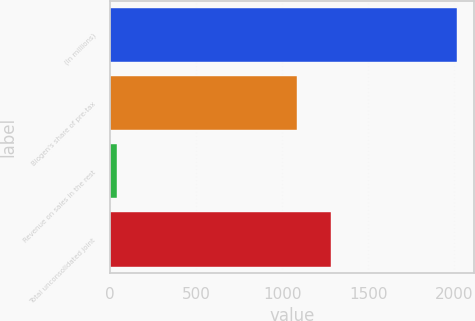Convert chart to OTSL. <chart><loc_0><loc_0><loc_500><loc_500><bar_chart><fcel>(In millions)<fcel>Biogen's share of pre-tax<fcel>Revenue on sales in the rest<fcel>Total unconsolidated joint<nl><fcel>2013<fcel>1087.3<fcel>38.7<fcel>1284.73<nl></chart> 